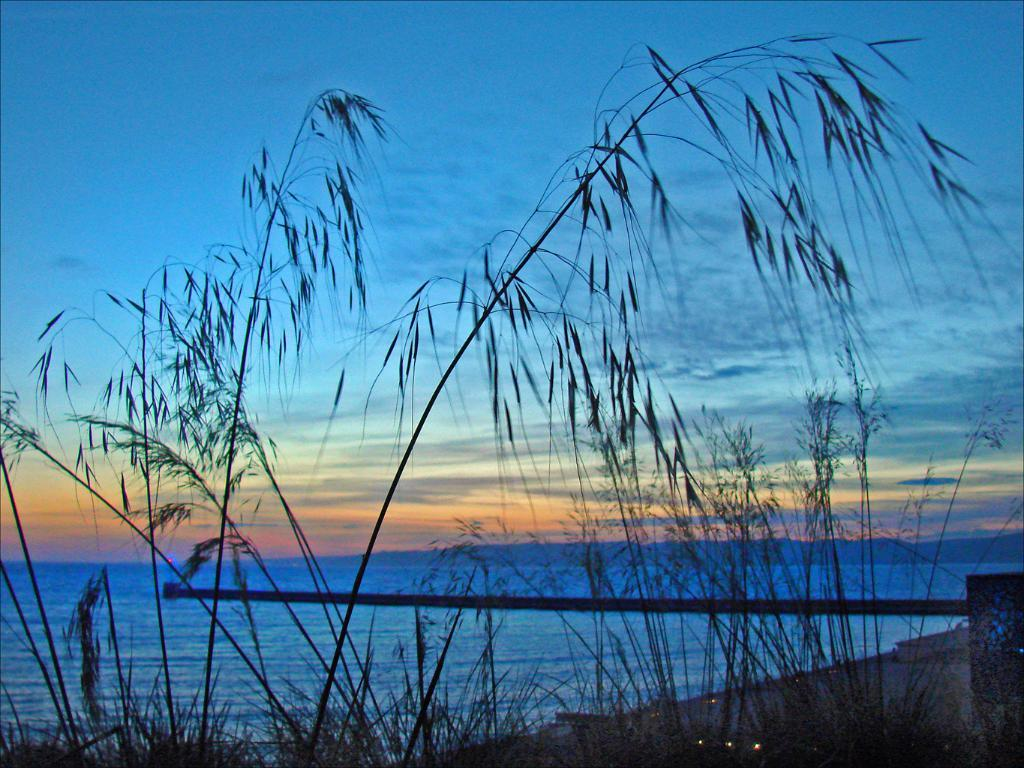What type of vegetation can be seen in the image? There is grass in the image. What can be seen illuminating the area in the image? There are lights visible in the image. What is visible in the background of the image? There is water and the sky in the background of the image. How would you describe the sky in the image? The sky appears to be cloudy in the image. What grade does the maid receive for her performance in the image? There is no maid present in the image, and therefore no performance to evaluate. 